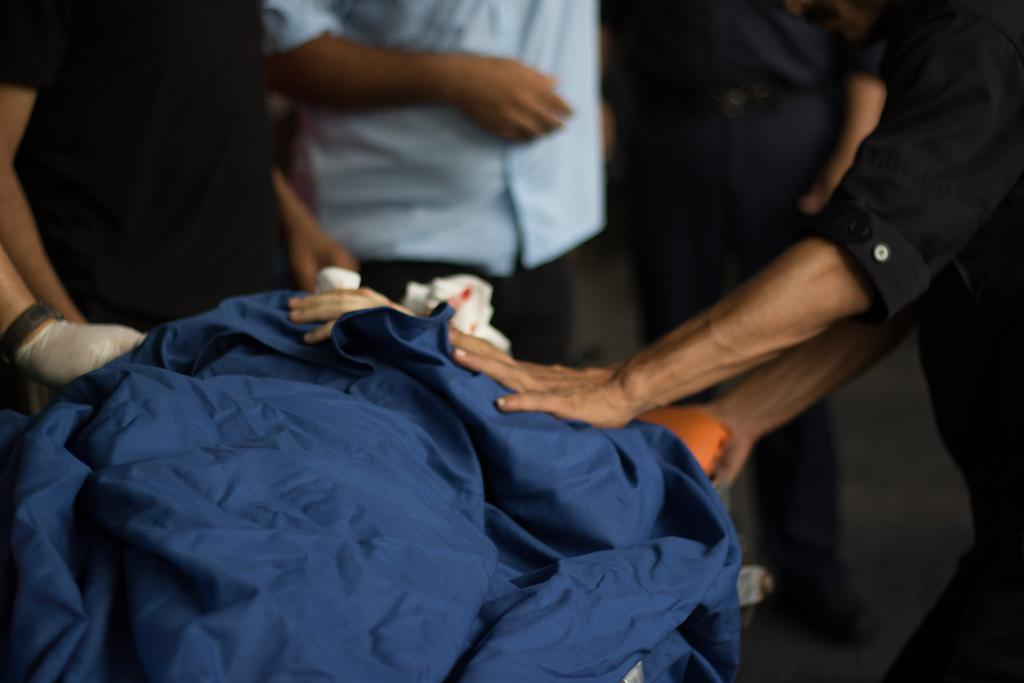What is the main object in the image? There is a cloth in the image. How many people are present in the image? There are four people in the image. What else can be seen in the image besides the cloth and people? There are some objects in the image. Can you describe the position of one of the people in the image? There is a person standing on the floor in the image. How many mice are visible on the cloth in the image? There are no mice visible on the cloth in the image. What type of change is being made by the people in the image? The provided facts do not mention any changes being made by the people in the image. 